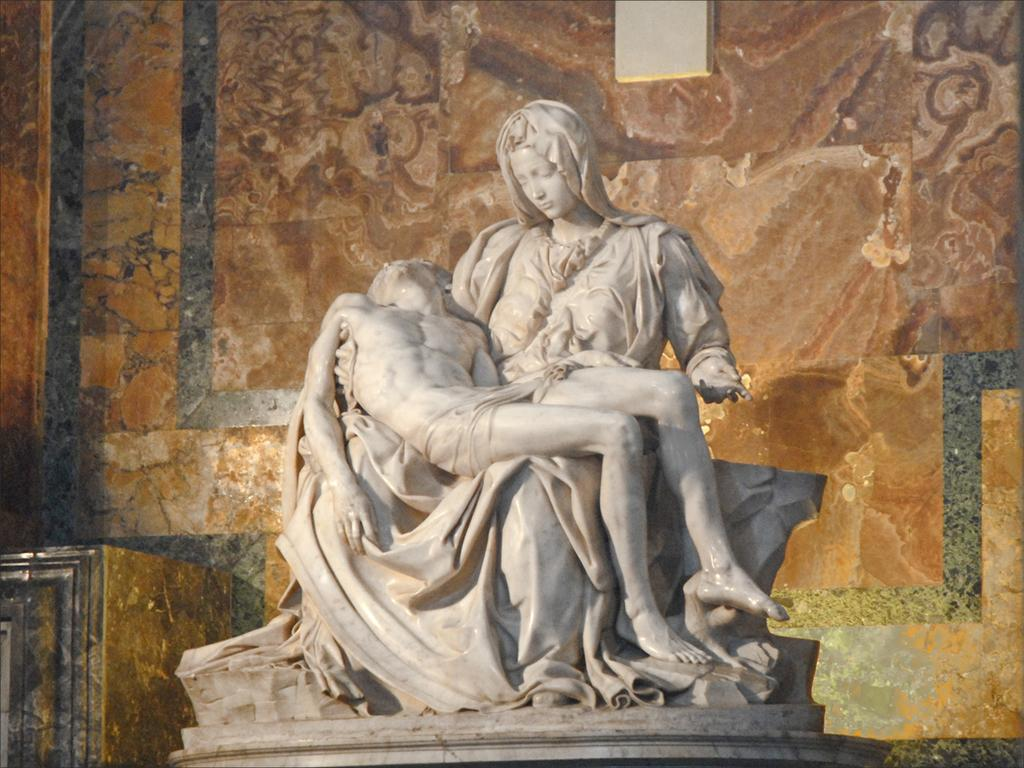What is the main subject of the image? There is a statue of a woman in the image. What is the woman in the statue doing? The woman is holding a person in her lap. What type of background can be seen in the image? There is a stone wall in the image. What color is the lip of the person being held by the statue? There is no lip visible in the image, as the person being held is not a real person but a part of the statue. 